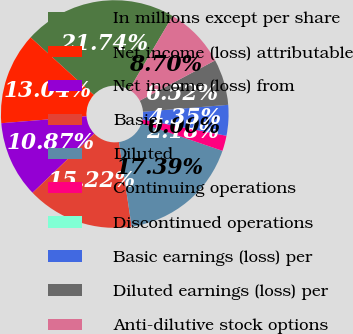<chart> <loc_0><loc_0><loc_500><loc_500><pie_chart><fcel>In millions except per share<fcel>Net income (loss) attributable<fcel>Net income (loss) from<fcel>Basic<fcel>Diluted<fcel>Continuing operations<fcel>Discontinued operations<fcel>Basic earnings (loss) per<fcel>Diluted earnings (loss) per<fcel>Anti-dilutive stock options<nl><fcel>21.74%<fcel>13.04%<fcel>10.87%<fcel>15.22%<fcel>17.39%<fcel>2.18%<fcel>0.0%<fcel>4.35%<fcel>6.52%<fcel>8.7%<nl></chart> 